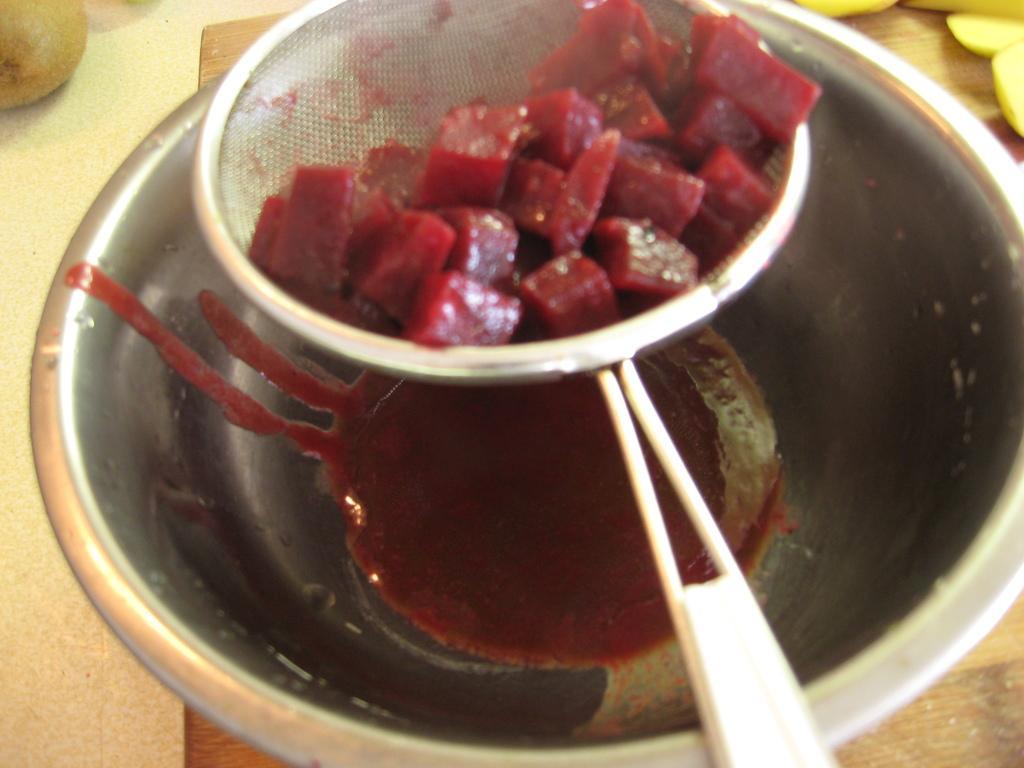In one or two sentences, can you explain what this image depicts? In the image we can see there are beetroot pieces kept on the strainer. There is a juice in the bowl and there are other fruits kept on the table. 